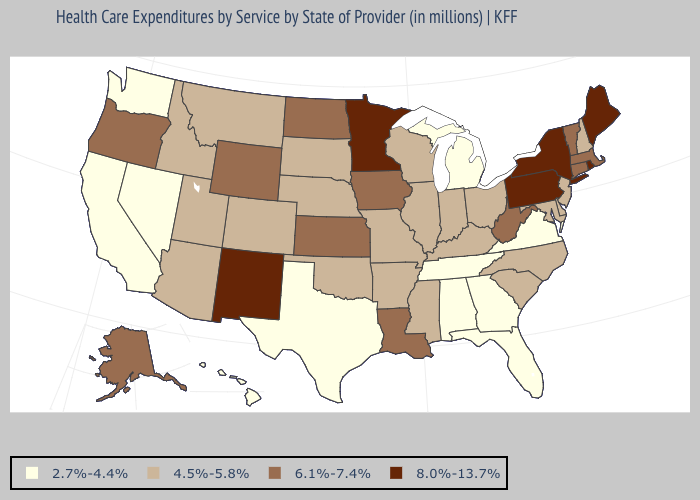Does Tennessee have the lowest value in the USA?
Write a very short answer. Yes. What is the lowest value in the USA?
Write a very short answer. 2.7%-4.4%. Is the legend a continuous bar?
Quick response, please. No. Among the states that border Florida , which have the highest value?
Give a very brief answer. Alabama, Georgia. What is the highest value in states that border Idaho?
Short answer required. 6.1%-7.4%. What is the lowest value in states that border Vermont?
Keep it brief. 4.5%-5.8%. Is the legend a continuous bar?
Quick response, please. No. Name the states that have a value in the range 4.5%-5.8%?
Keep it brief. Arizona, Arkansas, Colorado, Delaware, Idaho, Illinois, Indiana, Kentucky, Maryland, Mississippi, Missouri, Montana, Nebraska, New Hampshire, New Jersey, North Carolina, Ohio, Oklahoma, South Carolina, South Dakota, Utah, Wisconsin. What is the value of Nebraska?
Give a very brief answer. 4.5%-5.8%. Name the states that have a value in the range 2.7%-4.4%?
Concise answer only. Alabama, California, Florida, Georgia, Hawaii, Michigan, Nevada, Tennessee, Texas, Virginia, Washington. Name the states that have a value in the range 6.1%-7.4%?
Write a very short answer. Alaska, Connecticut, Iowa, Kansas, Louisiana, Massachusetts, North Dakota, Oregon, Vermont, West Virginia, Wyoming. Which states have the lowest value in the USA?
Write a very short answer. Alabama, California, Florida, Georgia, Hawaii, Michigan, Nevada, Tennessee, Texas, Virginia, Washington. What is the lowest value in the USA?
Answer briefly. 2.7%-4.4%. Which states have the highest value in the USA?
Be succinct. Maine, Minnesota, New Mexico, New York, Pennsylvania, Rhode Island. Does New Jersey have the highest value in the Northeast?
Concise answer only. No. 